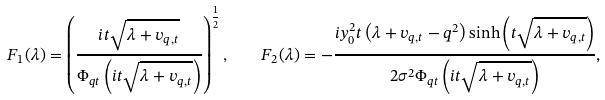Convert formula to latex. <formula><loc_0><loc_0><loc_500><loc_500>F _ { 1 } ( \lambda ) = \left ( \frac { i t \sqrt { \lambda + v _ { q , t } } } { \Phi _ { q t } \left ( i t \sqrt { \lambda + v _ { q , t } } \right ) } \right ) ^ { \frac { 1 } { 2 } } , \quad F _ { 2 } ( \lambda ) = - \frac { i y _ { 0 } ^ { 2 } t \left ( \lambda + v _ { q , t } - q ^ { 2 } \right ) \sinh \left ( t \sqrt { \lambda + v _ { q , t } } \right ) } { 2 \sigma ^ { 2 } \Phi _ { q t } \left ( i t \sqrt { \lambda + v _ { q , t } } \right ) } ,</formula> 